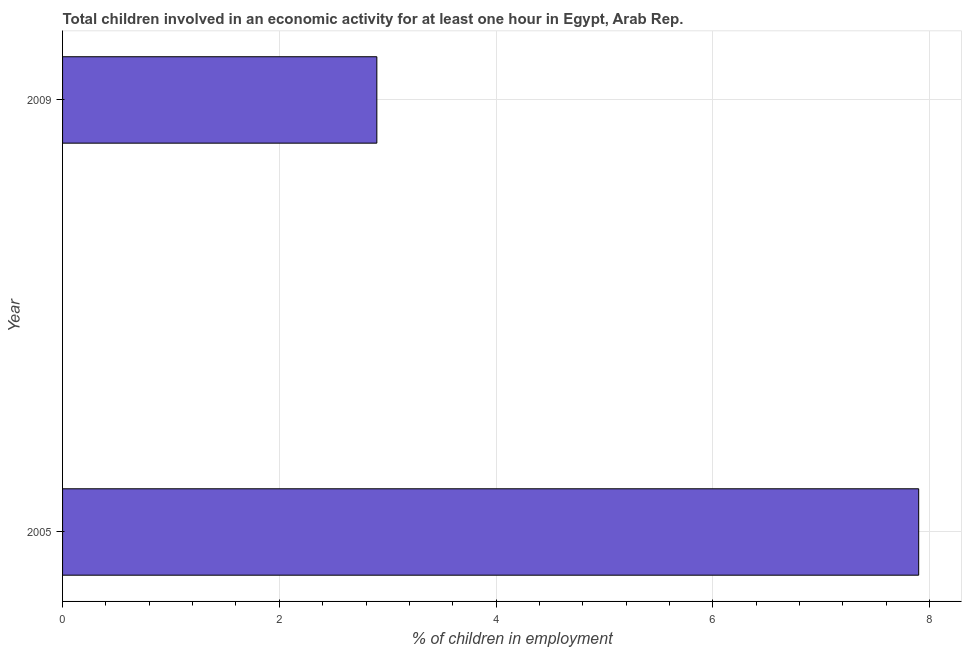Does the graph contain any zero values?
Ensure brevity in your answer.  No. Does the graph contain grids?
Your answer should be very brief. Yes. What is the title of the graph?
Provide a short and direct response. Total children involved in an economic activity for at least one hour in Egypt, Arab Rep. What is the label or title of the X-axis?
Offer a terse response. % of children in employment. Across all years, what is the maximum percentage of children in employment?
Your answer should be very brief. 7.9. Across all years, what is the minimum percentage of children in employment?
Your answer should be compact. 2.9. What is the difference between the percentage of children in employment in 2005 and 2009?
Your response must be concise. 5. What is the average percentage of children in employment per year?
Give a very brief answer. 5.4. In how many years, is the percentage of children in employment greater than 2.4 %?
Give a very brief answer. 2. What is the ratio of the percentage of children in employment in 2005 to that in 2009?
Make the answer very short. 2.72. Is the percentage of children in employment in 2005 less than that in 2009?
Your answer should be very brief. No. Are all the bars in the graph horizontal?
Give a very brief answer. Yes. What is the ratio of the % of children in employment in 2005 to that in 2009?
Make the answer very short. 2.72. 